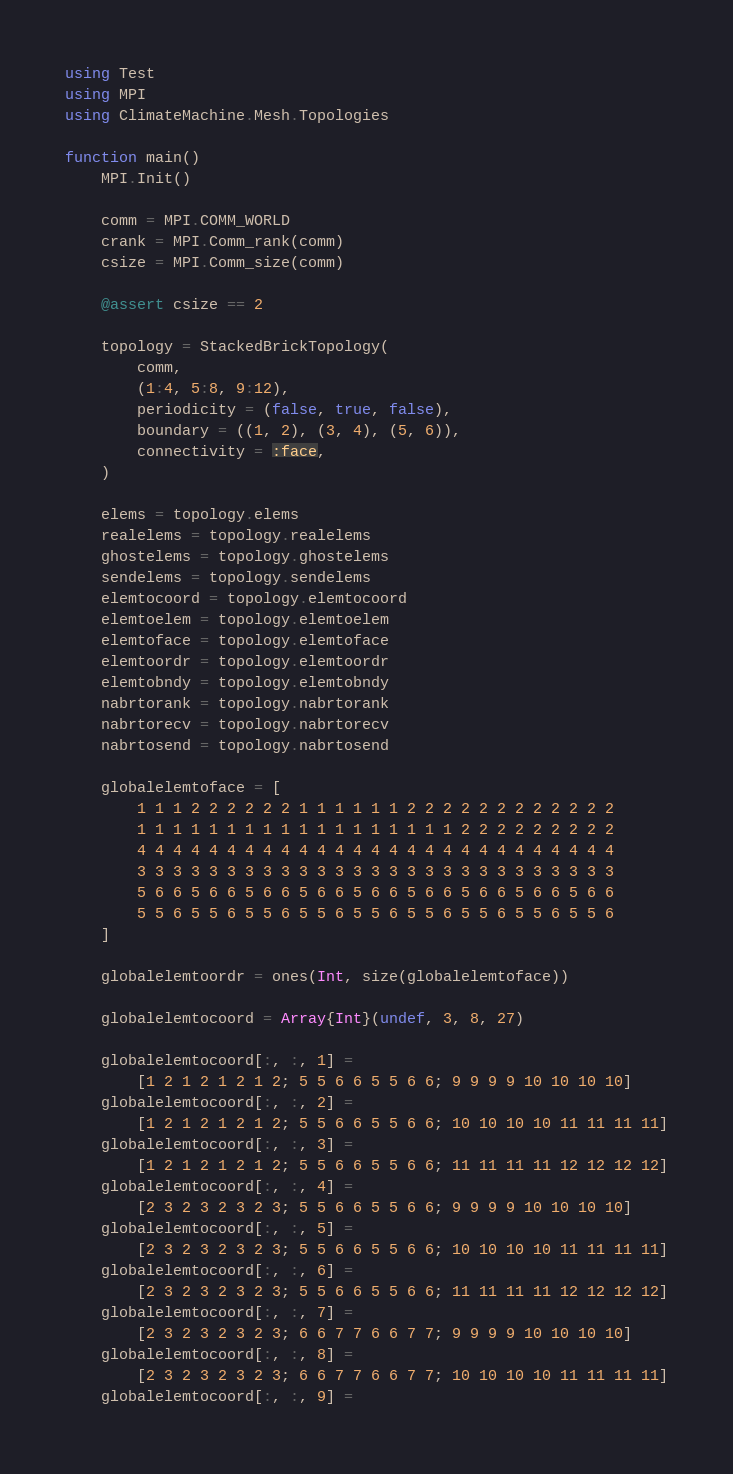Convert code to text. <code><loc_0><loc_0><loc_500><loc_500><_Julia_>using Test
using MPI
using ClimateMachine.Mesh.Topologies

function main()
    MPI.Init()

    comm = MPI.COMM_WORLD
    crank = MPI.Comm_rank(comm)
    csize = MPI.Comm_size(comm)

    @assert csize == 2

    topology = StackedBrickTopology(
        comm,
        (1:4, 5:8, 9:12),
        periodicity = (false, true, false),
        boundary = ((1, 2), (3, 4), (5, 6)),
        connectivity = :face,
    )

    elems = topology.elems
    realelems = topology.realelems
    ghostelems = topology.ghostelems
    sendelems = topology.sendelems
    elemtocoord = topology.elemtocoord
    elemtoelem = topology.elemtoelem
    elemtoface = topology.elemtoface
    elemtoordr = topology.elemtoordr
    elemtobndy = topology.elemtobndy
    nabrtorank = topology.nabrtorank
    nabrtorecv = topology.nabrtorecv
    nabrtosend = topology.nabrtosend

    globalelemtoface = [
        1 1 1 2 2 2 2 2 2 1 1 1 1 1 1 2 2 2 2 2 2 2 2 2 2 2 2
        1 1 1 1 1 1 1 1 1 1 1 1 1 1 1 1 1 1 2 2 2 2 2 2 2 2 2
        4 4 4 4 4 4 4 4 4 4 4 4 4 4 4 4 4 4 4 4 4 4 4 4 4 4 4
        3 3 3 3 3 3 3 3 3 3 3 3 3 3 3 3 3 3 3 3 3 3 3 3 3 3 3
        5 6 6 5 6 6 5 6 6 5 6 6 5 6 6 5 6 6 5 6 6 5 6 6 5 6 6
        5 5 6 5 5 6 5 5 6 5 5 6 5 5 6 5 5 6 5 5 6 5 5 6 5 5 6
    ]

    globalelemtoordr = ones(Int, size(globalelemtoface))

    globalelemtocoord = Array{Int}(undef, 3, 8, 27)

    globalelemtocoord[:, :, 1] =
        [1 2 1 2 1 2 1 2; 5 5 6 6 5 5 6 6; 9 9 9 9 10 10 10 10]
    globalelemtocoord[:, :, 2] =
        [1 2 1 2 1 2 1 2; 5 5 6 6 5 5 6 6; 10 10 10 10 11 11 11 11]
    globalelemtocoord[:, :, 3] =
        [1 2 1 2 1 2 1 2; 5 5 6 6 5 5 6 6; 11 11 11 11 12 12 12 12]
    globalelemtocoord[:, :, 4] =
        [2 3 2 3 2 3 2 3; 5 5 6 6 5 5 6 6; 9 9 9 9 10 10 10 10]
    globalelemtocoord[:, :, 5] =
        [2 3 2 3 2 3 2 3; 5 5 6 6 5 5 6 6; 10 10 10 10 11 11 11 11]
    globalelemtocoord[:, :, 6] =
        [2 3 2 3 2 3 2 3; 5 5 6 6 5 5 6 6; 11 11 11 11 12 12 12 12]
    globalelemtocoord[:, :, 7] =
        [2 3 2 3 2 3 2 3; 6 6 7 7 6 6 7 7; 9 9 9 9 10 10 10 10]
    globalelemtocoord[:, :, 8] =
        [2 3 2 3 2 3 2 3; 6 6 7 7 6 6 7 7; 10 10 10 10 11 11 11 11]
    globalelemtocoord[:, :, 9] =</code> 